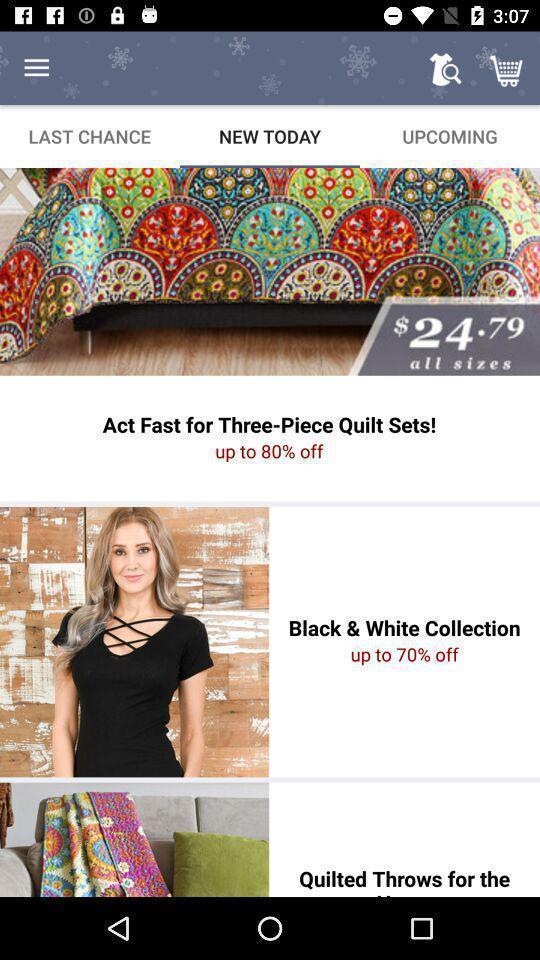Summarize the main components in this picture. Page showing list of collections on an e-commerce app. 